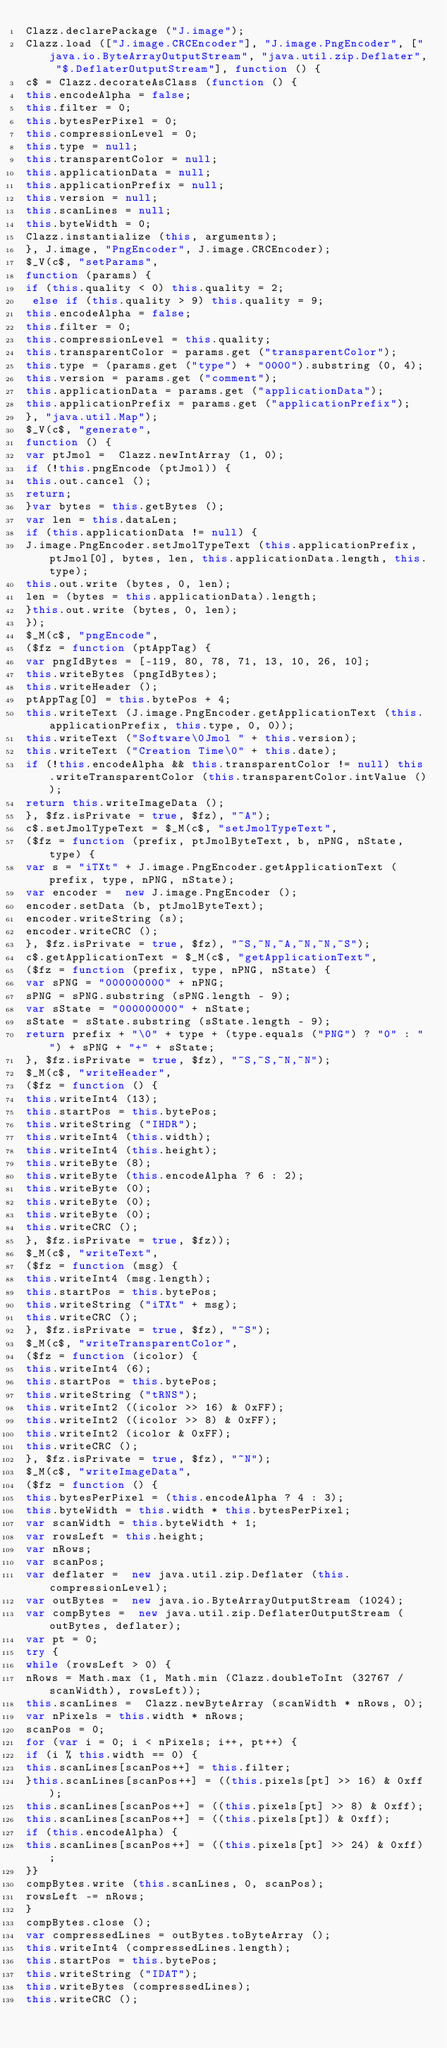Convert code to text. <code><loc_0><loc_0><loc_500><loc_500><_JavaScript_>Clazz.declarePackage ("J.image");
Clazz.load (["J.image.CRCEncoder"], "J.image.PngEncoder", ["java.io.ByteArrayOutputStream", "java.util.zip.Deflater", "$.DeflaterOutputStream"], function () {
c$ = Clazz.decorateAsClass (function () {
this.encodeAlpha = false;
this.filter = 0;
this.bytesPerPixel = 0;
this.compressionLevel = 0;
this.type = null;
this.transparentColor = null;
this.applicationData = null;
this.applicationPrefix = null;
this.version = null;
this.scanLines = null;
this.byteWidth = 0;
Clazz.instantialize (this, arguments);
}, J.image, "PngEncoder", J.image.CRCEncoder);
$_V(c$, "setParams", 
function (params) {
if (this.quality < 0) this.quality = 2;
 else if (this.quality > 9) this.quality = 9;
this.encodeAlpha = false;
this.filter = 0;
this.compressionLevel = this.quality;
this.transparentColor = params.get ("transparentColor");
this.type = (params.get ("type") + "0000").substring (0, 4);
this.version = params.get ("comment");
this.applicationData = params.get ("applicationData");
this.applicationPrefix = params.get ("applicationPrefix");
}, "java.util.Map");
$_V(c$, "generate", 
function () {
var ptJmol =  Clazz.newIntArray (1, 0);
if (!this.pngEncode (ptJmol)) {
this.out.cancel ();
return;
}var bytes = this.getBytes ();
var len = this.dataLen;
if (this.applicationData != null) {
J.image.PngEncoder.setJmolTypeText (this.applicationPrefix, ptJmol[0], bytes, len, this.applicationData.length, this.type);
this.out.write (bytes, 0, len);
len = (bytes = this.applicationData).length;
}this.out.write (bytes, 0, len);
});
$_M(c$, "pngEncode", 
($fz = function (ptAppTag) {
var pngIdBytes = [-119, 80, 78, 71, 13, 10, 26, 10];
this.writeBytes (pngIdBytes);
this.writeHeader ();
ptAppTag[0] = this.bytePos + 4;
this.writeText (J.image.PngEncoder.getApplicationText (this.applicationPrefix, this.type, 0, 0));
this.writeText ("Software\0Jmol " + this.version);
this.writeText ("Creation Time\0" + this.date);
if (!this.encodeAlpha && this.transparentColor != null) this.writeTransparentColor (this.transparentColor.intValue ());
return this.writeImageData ();
}, $fz.isPrivate = true, $fz), "~A");
c$.setJmolTypeText = $_M(c$, "setJmolTypeText", 
($fz = function (prefix, ptJmolByteText, b, nPNG, nState, type) {
var s = "iTXt" + J.image.PngEncoder.getApplicationText (prefix, type, nPNG, nState);
var encoder =  new J.image.PngEncoder ();
encoder.setData (b, ptJmolByteText);
encoder.writeString (s);
encoder.writeCRC ();
}, $fz.isPrivate = true, $fz), "~S,~N,~A,~N,~N,~S");
c$.getApplicationText = $_M(c$, "getApplicationText", 
($fz = function (prefix, type, nPNG, nState) {
var sPNG = "000000000" + nPNG;
sPNG = sPNG.substring (sPNG.length - 9);
var sState = "000000000" + nState;
sState = sState.substring (sState.length - 9);
return prefix + "\0" + type + (type.equals ("PNG") ? "0" : "") + sPNG + "+" + sState;
}, $fz.isPrivate = true, $fz), "~S,~S,~N,~N");
$_M(c$, "writeHeader", 
($fz = function () {
this.writeInt4 (13);
this.startPos = this.bytePos;
this.writeString ("IHDR");
this.writeInt4 (this.width);
this.writeInt4 (this.height);
this.writeByte (8);
this.writeByte (this.encodeAlpha ? 6 : 2);
this.writeByte (0);
this.writeByte (0);
this.writeByte (0);
this.writeCRC ();
}, $fz.isPrivate = true, $fz));
$_M(c$, "writeText", 
($fz = function (msg) {
this.writeInt4 (msg.length);
this.startPos = this.bytePos;
this.writeString ("iTXt" + msg);
this.writeCRC ();
}, $fz.isPrivate = true, $fz), "~S");
$_M(c$, "writeTransparentColor", 
($fz = function (icolor) {
this.writeInt4 (6);
this.startPos = this.bytePos;
this.writeString ("tRNS");
this.writeInt2 ((icolor >> 16) & 0xFF);
this.writeInt2 ((icolor >> 8) & 0xFF);
this.writeInt2 (icolor & 0xFF);
this.writeCRC ();
}, $fz.isPrivate = true, $fz), "~N");
$_M(c$, "writeImageData", 
($fz = function () {
this.bytesPerPixel = (this.encodeAlpha ? 4 : 3);
this.byteWidth = this.width * this.bytesPerPixel;
var scanWidth = this.byteWidth + 1;
var rowsLeft = this.height;
var nRows;
var scanPos;
var deflater =  new java.util.zip.Deflater (this.compressionLevel);
var outBytes =  new java.io.ByteArrayOutputStream (1024);
var compBytes =  new java.util.zip.DeflaterOutputStream (outBytes, deflater);
var pt = 0;
try {
while (rowsLeft > 0) {
nRows = Math.max (1, Math.min (Clazz.doubleToInt (32767 / scanWidth), rowsLeft));
this.scanLines =  Clazz.newByteArray (scanWidth * nRows, 0);
var nPixels = this.width * nRows;
scanPos = 0;
for (var i = 0; i < nPixels; i++, pt++) {
if (i % this.width == 0) {
this.scanLines[scanPos++] = this.filter;
}this.scanLines[scanPos++] = ((this.pixels[pt] >> 16) & 0xff);
this.scanLines[scanPos++] = ((this.pixels[pt] >> 8) & 0xff);
this.scanLines[scanPos++] = ((this.pixels[pt]) & 0xff);
if (this.encodeAlpha) {
this.scanLines[scanPos++] = ((this.pixels[pt] >> 24) & 0xff);
}}
compBytes.write (this.scanLines, 0, scanPos);
rowsLeft -= nRows;
}
compBytes.close ();
var compressedLines = outBytes.toByteArray ();
this.writeInt4 (compressedLines.length);
this.startPos = this.bytePos;
this.writeString ("IDAT");
this.writeBytes (compressedLines);
this.writeCRC ();</code> 